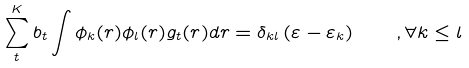Convert formula to latex. <formula><loc_0><loc_0><loc_500><loc_500>\sum _ { t } ^ { K } b _ { t } \int \phi _ { k } ( r ) \phi _ { l } ( r ) g _ { t } ( r ) d r = \delta _ { k l } \left ( \varepsilon - \varepsilon _ { k } \right ) \quad , \forall k \leq l</formula> 